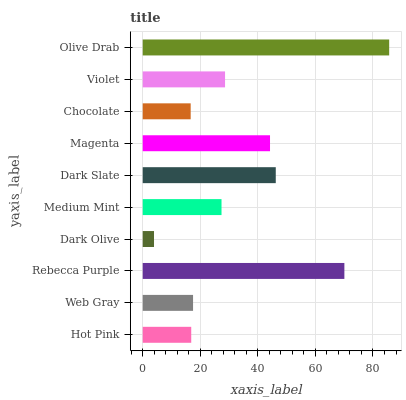Is Dark Olive the minimum?
Answer yes or no. Yes. Is Olive Drab the maximum?
Answer yes or no. Yes. Is Web Gray the minimum?
Answer yes or no. No. Is Web Gray the maximum?
Answer yes or no. No. Is Web Gray greater than Hot Pink?
Answer yes or no. Yes. Is Hot Pink less than Web Gray?
Answer yes or no. Yes. Is Hot Pink greater than Web Gray?
Answer yes or no. No. Is Web Gray less than Hot Pink?
Answer yes or no. No. Is Violet the high median?
Answer yes or no. Yes. Is Medium Mint the low median?
Answer yes or no. Yes. Is Rebecca Purple the high median?
Answer yes or no. No. Is Rebecca Purple the low median?
Answer yes or no. No. 